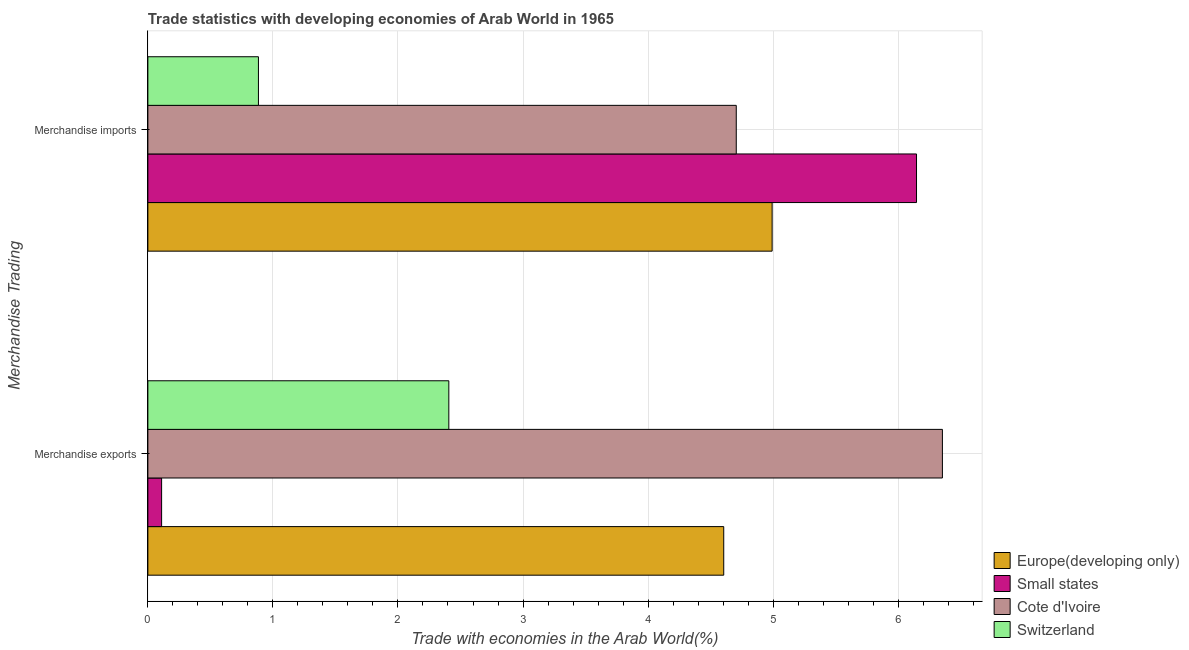How many groups of bars are there?
Make the answer very short. 2. Are the number of bars per tick equal to the number of legend labels?
Your response must be concise. Yes. Are the number of bars on each tick of the Y-axis equal?
Your answer should be very brief. Yes. How many bars are there on the 1st tick from the top?
Ensure brevity in your answer.  4. How many bars are there on the 1st tick from the bottom?
Your answer should be very brief. 4. What is the merchandise imports in Switzerland?
Provide a short and direct response. 0.88. Across all countries, what is the maximum merchandise imports?
Offer a terse response. 6.15. Across all countries, what is the minimum merchandise exports?
Offer a very short reply. 0.11. In which country was the merchandise exports maximum?
Keep it short and to the point. Cote d'Ivoire. In which country was the merchandise imports minimum?
Provide a succinct answer. Switzerland. What is the total merchandise imports in the graph?
Give a very brief answer. 16.73. What is the difference between the merchandise exports in Europe(developing only) and that in Cote d'Ivoire?
Ensure brevity in your answer.  -1.75. What is the difference between the merchandise exports in Switzerland and the merchandise imports in Europe(developing only)?
Your answer should be very brief. -2.59. What is the average merchandise exports per country?
Give a very brief answer. 3.37. What is the difference between the merchandise exports and merchandise imports in Small states?
Provide a succinct answer. -6.04. In how many countries, is the merchandise imports greater than 3.8 %?
Provide a succinct answer. 3. What is the ratio of the merchandise imports in Europe(developing only) to that in Small states?
Your answer should be very brief. 0.81. Is the merchandise imports in Cote d'Ivoire less than that in Europe(developing only)?
Provide a short and direct response. Yes. In how many countries, is the merchandise exports greater than the average merchandise exports taken over all countries?
Your answer should be compact. 2. What does the 1st bar from the top in Merchandise exports represents?
Provide a succinct answer. Switzerland. What does the 1st bar from the bottom in Merchandise exports represents?
Ensure brevity in your answer.  Europe(developing only). Are all the bars in the graph horizontal?
Keep it short and to the point. Yes. Are the values on the major ticks of X-axis written in scientific E-notation?
Offer a terse response. No. Does the graph contain any zero values?
Provide a short and direct response. No. Does the graph contain grids?
Your response must be concise. Yes. What is the title of the graph?
Keep it short and to the point. Trade statistics with developing economies of Arab World in 1965. What is the label or title of the X-axis?
Provide a succinct answer. Trade with economies in the Arab World(%). What is the label or title of the Y-axis?
Offer a terse response. Merchandise Trading. What is the Trade with economies in the Arab World(%) of Europe(developing only) in Merchandise exports?
Your response must be concise. 4.61. What is the Trade with economies in the Arab World(%) in Small states in Merchandise exports?
Ensure brevity in your answer.  0.11. What is the Trade with economies in the Arab World(%) in Cote d'Ivoire in Merchandise exports?
Your response must be concise. 6.35. What is the Trade with economies in the Arab World(%) in Switzerland in Merchandise exports?
Your answer should be compact. 2.41. What is the Trade with economies in the Arab World(%) in Europe(developing only) in Merchandise imports?
Make the answer very short. 4.99. What is the Trade with economies in the Arab World(%) in Small states in Merchandise imports?
Ensure brevity in your answer.  6.15. What is the Trade with economies in the Arab World(%) of Cote d'Ivoire in Merchandise imports?
Your answer should be very brief. 4.71. What is the Trade with economies in the Arab World(%) in Switzerland in Merchandise imports?
Ensure brevity in your answer.  0.88. Across all Merchandise Trading, what is the maximum Trade with economies in the Arab World(%) in Europe(developing only)?
Ensure brevity in your answer.  4.99. Across all Merchandise Trading, what is the maximum Trade with economies in the Arab World(%) of Small states?
Your answer should be compact. 6.15. Across all Merchandise Trading, what is the maximum Trade with economies in the Arab World(%) of Cote d'Ivoire?
Your answer should be very brief. 6.35. Across all Merchandise Trading, what is the maximum Trade with economies in the Arab World(%) of Switzerland?
Your answer should be very brief. 2.41. Across all Merchandise Trading, what is the minimum Trade with economies in the Arab World(%) of Europe(developing only)?
Your response must be concise. 4.61. Across all Merchandise Trading, what is the minimum Trade with economies in the Arab World(%) of Small states?
Provide a short and direct response. 0.11. Across all Merchandise Trading, what is the minimum Trade with economies in the Arab World(%) in Cote d'Ivoire?
Ensure brevity in your answer.  4.71. Across all Merchandise Trading, what is the minimum Trade with economies in the Arab World(%) in Switzerland?
Your response must be concise. 0.88. What is the total Trade with economies in the Arab World(%) of Europe(developing only) in the graph?
Offer a terse response. 9.6. What is the total Trade with economies in the Arab World(%) of Small states in the graph?
Your answer should be compact. 6.26. What is the total Trade with economies in the Arab World(%) in Cote d'Ivoire in the graph?
Make the answer very short. 11.06. What is the total Trade with economies in the Arab World(%) of Switzerland in the graph?
Your answer should be compact. 3.29. What is the difference between the Trade with economies in the Arab World(%) of Europe(developing only) in Merchandise exports and that in Merchandise imports?
Offer a terse response. -0.39. What is the difference between the Trade with economies in the Arab World(%) in Small states in Merchandise exports and that in Merchandise imports?
Your answer should be compact. -6.04. What is the difference between the Trade with economies in the Arab World(%) in Cote d'Ivoire in Merchandise exports and that in Merchandise imports?
Your answer should be very brief. 1.65. What is the difference between the Trade with economies in the Arab World(%) of Switzerland in Merchandise exports and that in Merchandise imports?
Your answer should be compact. 1.52. What is the difference between the Trade with economies in the Arab World(%) in Europe(developing only) in Merchandise exports and the Trade with economies in the Arab World(%) in Small states in Merchandise imports?
Offer a very short reply. -1.54. What is the difference between the Trade with economies in the Arab World(%) in Europe(developing only) in Merchandise exports and the Trade with economies in the Arab World(%) in Cote d'Ivoire in Merchandise imports?
Provide a short and direct response. -0.1. What is the difference between the Trade with economies in the Arab World(%) in Europe(developing only) in Merchandise exports and the Trade with economies in the Arab World(%) in Switzerland in Merchandise imports?
Your answer should be compact. 3.72. What is the difference between the Trade with economies in the Arab World(%) in Small states in Merchandise exports and the Trade with economies in the Arab World(%) in Cote d'Ivoire in Merchandise imports?
Your answer should be very brief. -4.6. What is the difference between the Trade with economies in the Arab World(%) of Small states in Merchandise exports and the Trade with economies in the Arab World(%) of Switzerland in Merchandise imports?
Offer a very short reply. -0.77. What is the difference between the Trade with economies in the Arab World(%) of Cote d'Ivoire in Merchandise exports and the Trade with economies in the Arab World(%) of Switzerland in Merchandise imports?
Offer a terse response. 5.47. What is the average Trade with economies in the Arab World(%) of Europe(developing only) per Merchandise Trading?
Make the answer very short. 4.8. What is the average Trade with economies in the Arab World(%) of Small states per Merchandise Trading?
Your answer should be compact. 3.13. What is the average Trade with economies in the Arab World(%) in Cote d'Ivoire per Merchandise Trading?
Provide a short and direct response. 5.53. What is the average Trade with economies in the Arab World(%) of Switzerland per Merchandise Trading?
Your answer should be very brief. 1.65. What is the difference between the Trade with economies in the Arab World(%) of Europe(developing only) and Trade with economies in the Arab World(%) of Small states in Merchandise exports?
Offer a very short reply. 4.5. What is the difference between the Trade with economies in the Arab World(%) of Europe(developing only) and Trade with economies in the Arab World(%) of Cote d'Ivoire in Merchandise exports?
Your answer should be very brief. -1.75. What is the difference between the Trade with economies in the Arab World(%) of Europe(developing only) and Trade with economies in the Arab World(%) of Switzerland in Merchandise exports?
Provide a succinct answer. 2.2. What is the difference between the Trade with economies in the Arab World(%) in Small states and Trade with economies in the Arab World(%) in Cote d'Ivoire in Merchandise exports?
Your answer should be compact. -6.24. What is the difference between the Trade with economies in the Arab World(%) of Small states and Trade with economies in the Arab World(%) of Switzerland in Merchandise exports?
Your answer should be very brief. -2.3. What is the difference between the Trade with economies in the Arab World(%) of Cote d'Ivoire and Trade with economies in the Arab World(%) of Switzerland in Merchandise exports?
Provide a succinct answer. 3.95. What is the difference between the Trade with economies in the Arab World(%) of Europe(developing only) and Trade with economies in the Arab World(%) of Small states in Merchandise imports?
Your answer should be very brief. -1.15. What is the difference between the Trade with economies in the Arab World(%) of Europe(developing only) and Trade with economies in the Arab World(%) of Cote d'Ivoire in Merchandise imports?
Offer a terse response. 0.29. What is the difference between the Trade with economies in the Arab World(%) in Europe(developing only) and Trade with economies in the Arab World(%) in Switzerland in Merchandise imports?
Ensure brevity in your answer.  4.11. What is the difference between the Trade with economies in the Arab World(%) in Small states and Trade with economies in the Arab World(%) in Cote d'Ivoire in Merchandise imports?
Your response must be concise. 1.44. What is the difference between the Trade with economies in the Arab World(%) in Small states and Trade with economies in the Arab World(%) in Switzerland in Merchandise imports?
Offer a very short reply. 5.26. What is the difference between the Trade with economies in the Arab World(%) of Cote d'Ivoire and Trade with economies in the Arab World(%) of Switzerland in Merchandise imports?
Provide a succinct answer. 3.82. What is the ratio of the Trade with economies in the Arab World(%) in Europe(developing only) in Merchandise exports to that in Merchandise imports?
Keep it short and to the point. 0.92. What is the ratio of the Trade with economies in the Arab World(%) of Small states in Merchandise exports to that in Merchandise imports?
Keep it short and to the point. 0.02. What is the ratio of the Trade with economies in the Arab World(%) of Cote d'Ivoire in Merchandise exports to that in Merchandise imports?
Make the answer very short. 1.35. What is the ratio of the Trade with economies in the Arab World(%) of Switzerland in Merchandise exports to that in Merchandise imports?
Ensure brevity in your answer.  2.72. What is the difference between the highest and the second highest Trade with economies in the Arab World(%) in Europe(developing only)?
Provide a succinct answer. 0.39. What is the difference between the highest and the second highest Trade with economies in the Arab World(%) in Small states?
Provide a succinct answer. 6.04. What is the difference between the highest and the second highest Trade with economies in the Arab World(%) in Cote d'Ivoire?
Your answer should be very brief. 1.65. What is the difference between the highest and the second highest Trade with economies in the Arab World(%) of Switzerland?
Your response must be concise. 1.52. What is the difference between the highest and the lowest Trade with economies in the Arab World(%) in Europe(developing only)?
Offer a very short reply. 0.39. What is the difference between the highest and the lowest Trade with economies in the Arab World(%) in Small states?
Ensure brevity in your answer.  6.04. What is the difference between the highest and the lowest Trade with economies in the Arab World(%) in Cote d'Ivoire?
Give a very brief answer. 1.65. What is the difference between the highest and the lowest Trade with economies in the Arab World(%) of Switzerland?
Ensure brevity in your answer.  1.52. 